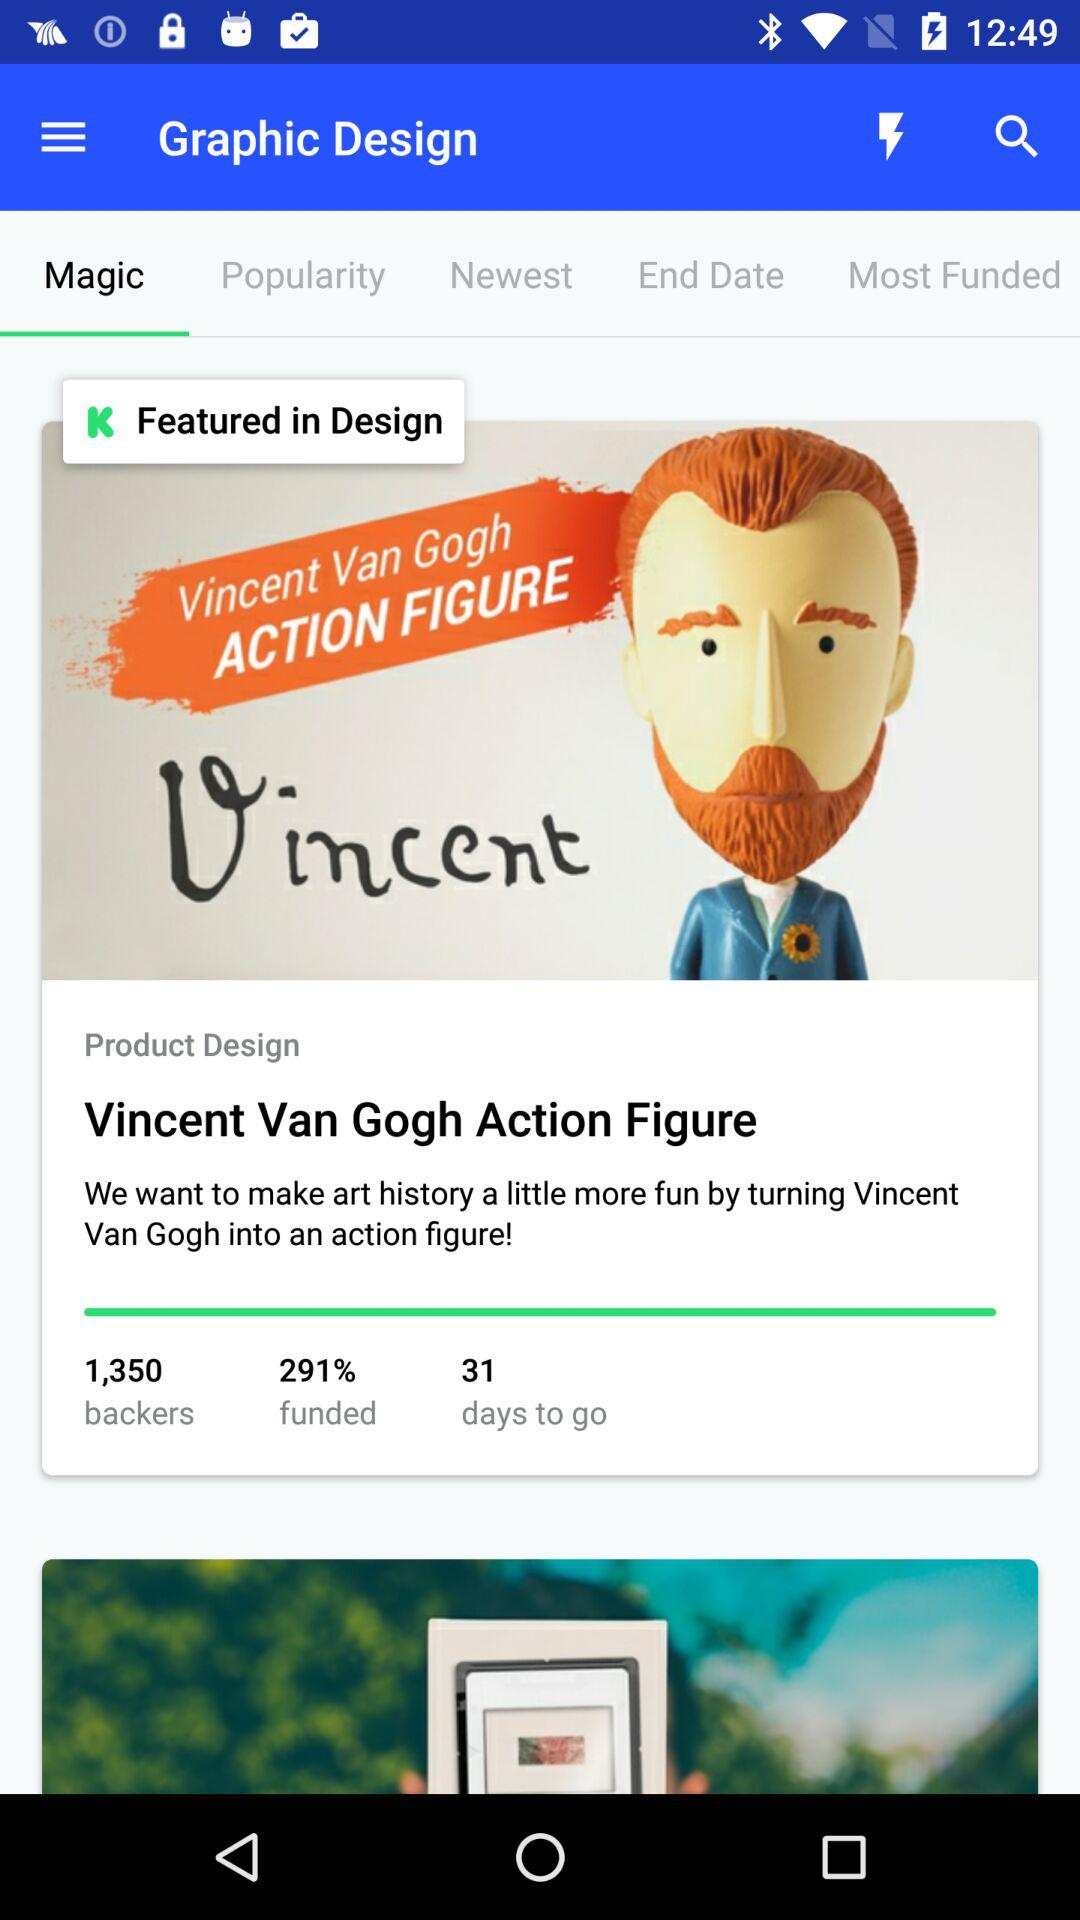What tab is selected? The selected tab is "Magic". 